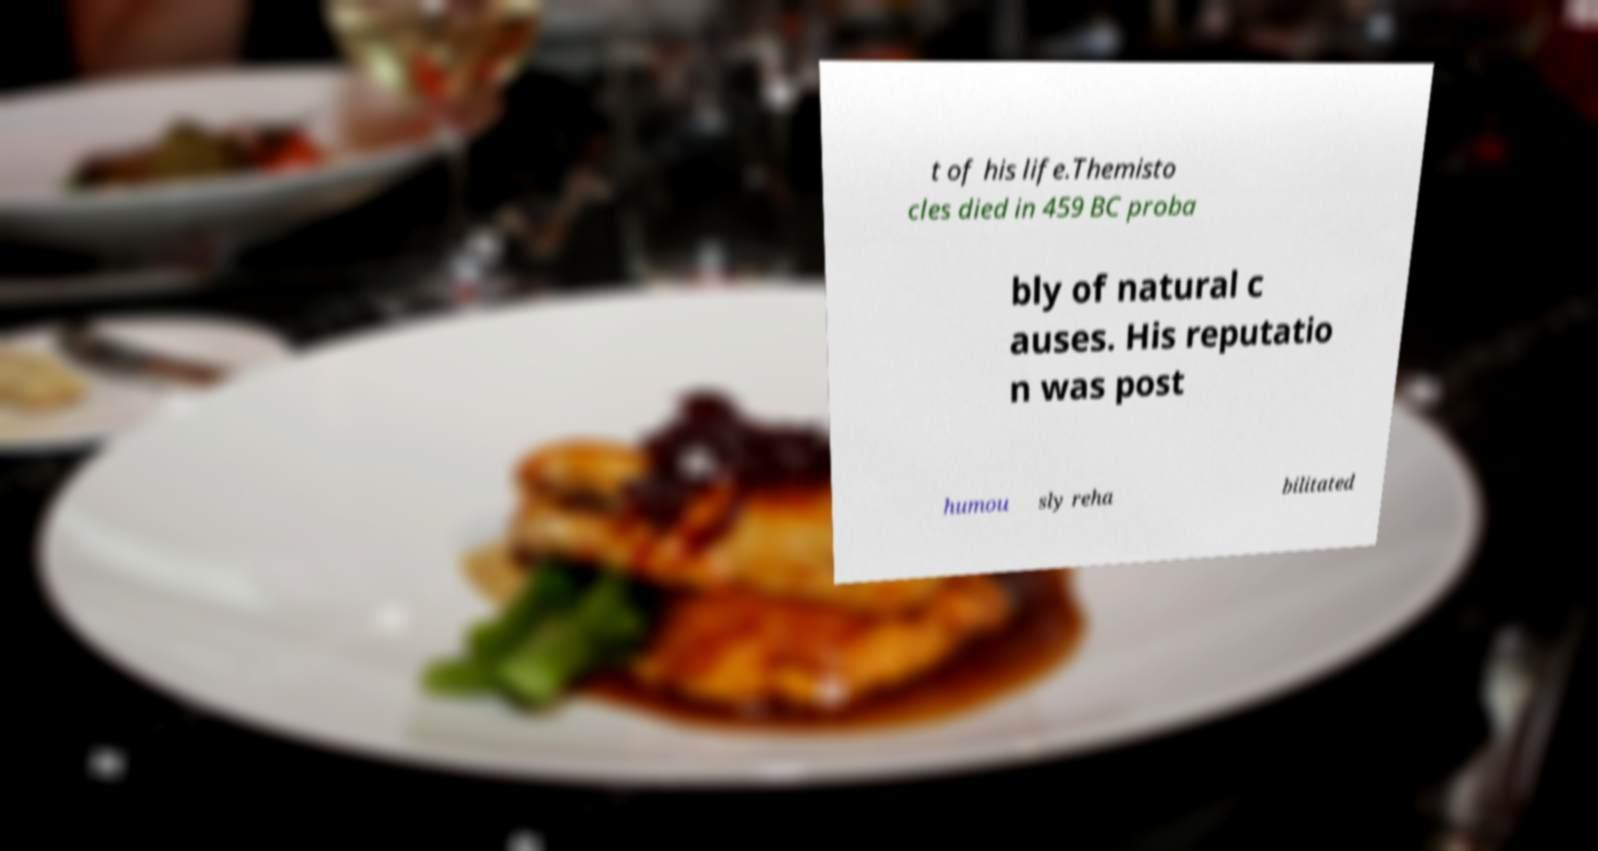For documentation purposes, I need the text within this image transcribed. Could you provide that? t of his life.Themisto cles died in 459 BC proba bly of natural c auses. His reputatio n was post humou sly reha bilitated 